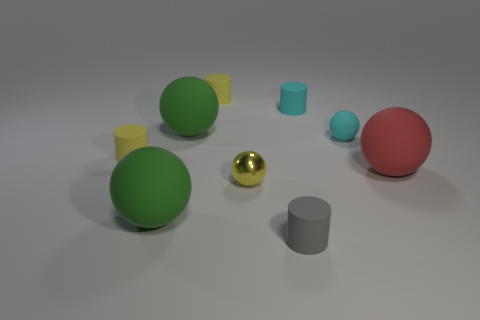Subtract 1 cylinders. How many cylinders are left? 3 Subtract all brown cylinders. Subtract all green blocks. How many cylinders are left? 4 Add 1 tiny yellow metal spheres. How many objects exist? 10 Subtract all cylinders. How many objects are left? 5 Subtract all rubber spheres. Subtract all red matte objects. How many objects are left? 4 Add 3 small yellow rubber things. How many small yellow rubber things are left? 5 Add 3 small yellow cylinders. How many small yellow cylinders exist? 5 Subtract 0 brown blocks. How many objects are left? 9 